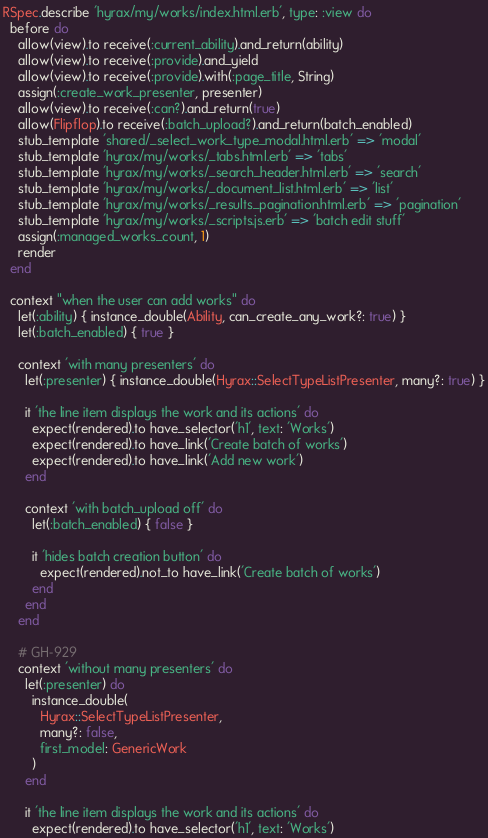<code> <loc_0><loc_0><loc_500><loc_500><_Ruby_>RSpec.describe 'hyrax/my/works/index.html.erb', type: :view do
  before do
    allow(view).to receive(:current_ability).and_return(ability)
    allow(view).to receive(:provide).and_yield
    allow(view).to receive(:provide).with(:page_title, String)
    assign(:create_work_presenter, presenter)
    allow(view).to receive(:can?).and_return(true)
    allow(Flipflop).to receive(:batch_upload?).and_return(batch_enabled)
    stub_template 'shared/_select_work_type_modal.html.erb' => 'modal'
    stub_template 'hyrax/my/works/_tabs.html.erb' => 'tabs'
    stub_template 'hyrax/my/works/_search_header.html.erb' => 'search'
    stub_template 'hyrax/my/works/_document_list.html.erb' => 'list'
    stub_template 'hyrax/my/works/_results_pagination.html.erb' => 'pagination'
    stub_template 'hyrax/my/works/_scripts.js.erb' => 'batch edit stuff'
    assign(:managed_works_count, 1)
    render
  end

  context "when the user can add works" do
    let(:ability) { instance_double(Ability, can_create_any_work?: true) }
    let(:batch_enabled) { true }

    context 'with many presenters' do
      let(:presenter) { instance_double(Hyrax::SelectTypeListPresenter, many?: true) }

      it 'the line item displays the work and its actions' do
        expect(rendered).to have_selector('h1', text: 'Works')
        expect(rendered).to have_link('Create batch of works')
        expect(rendered).to have_link('Add new work')
      end

      context 'with batch_upload off' do
        let(:batch_enabled) { false }

        it 'hides batch creation button' do
          expect(rendered).not_to have_link('Create batch of works')
        end
      end
    end

    # GH-929
    context 'without many presenters' do
      let(:presenter) do
        instance_double(
          Hyrax::SelectTypeListPresenter,
          many?: false,
          first_model: GenericWork
        )
      end

      it 'the line item displays the work and its actions' do
        expect(rendered).to have_selector('h1', text: 'Works')</code> 